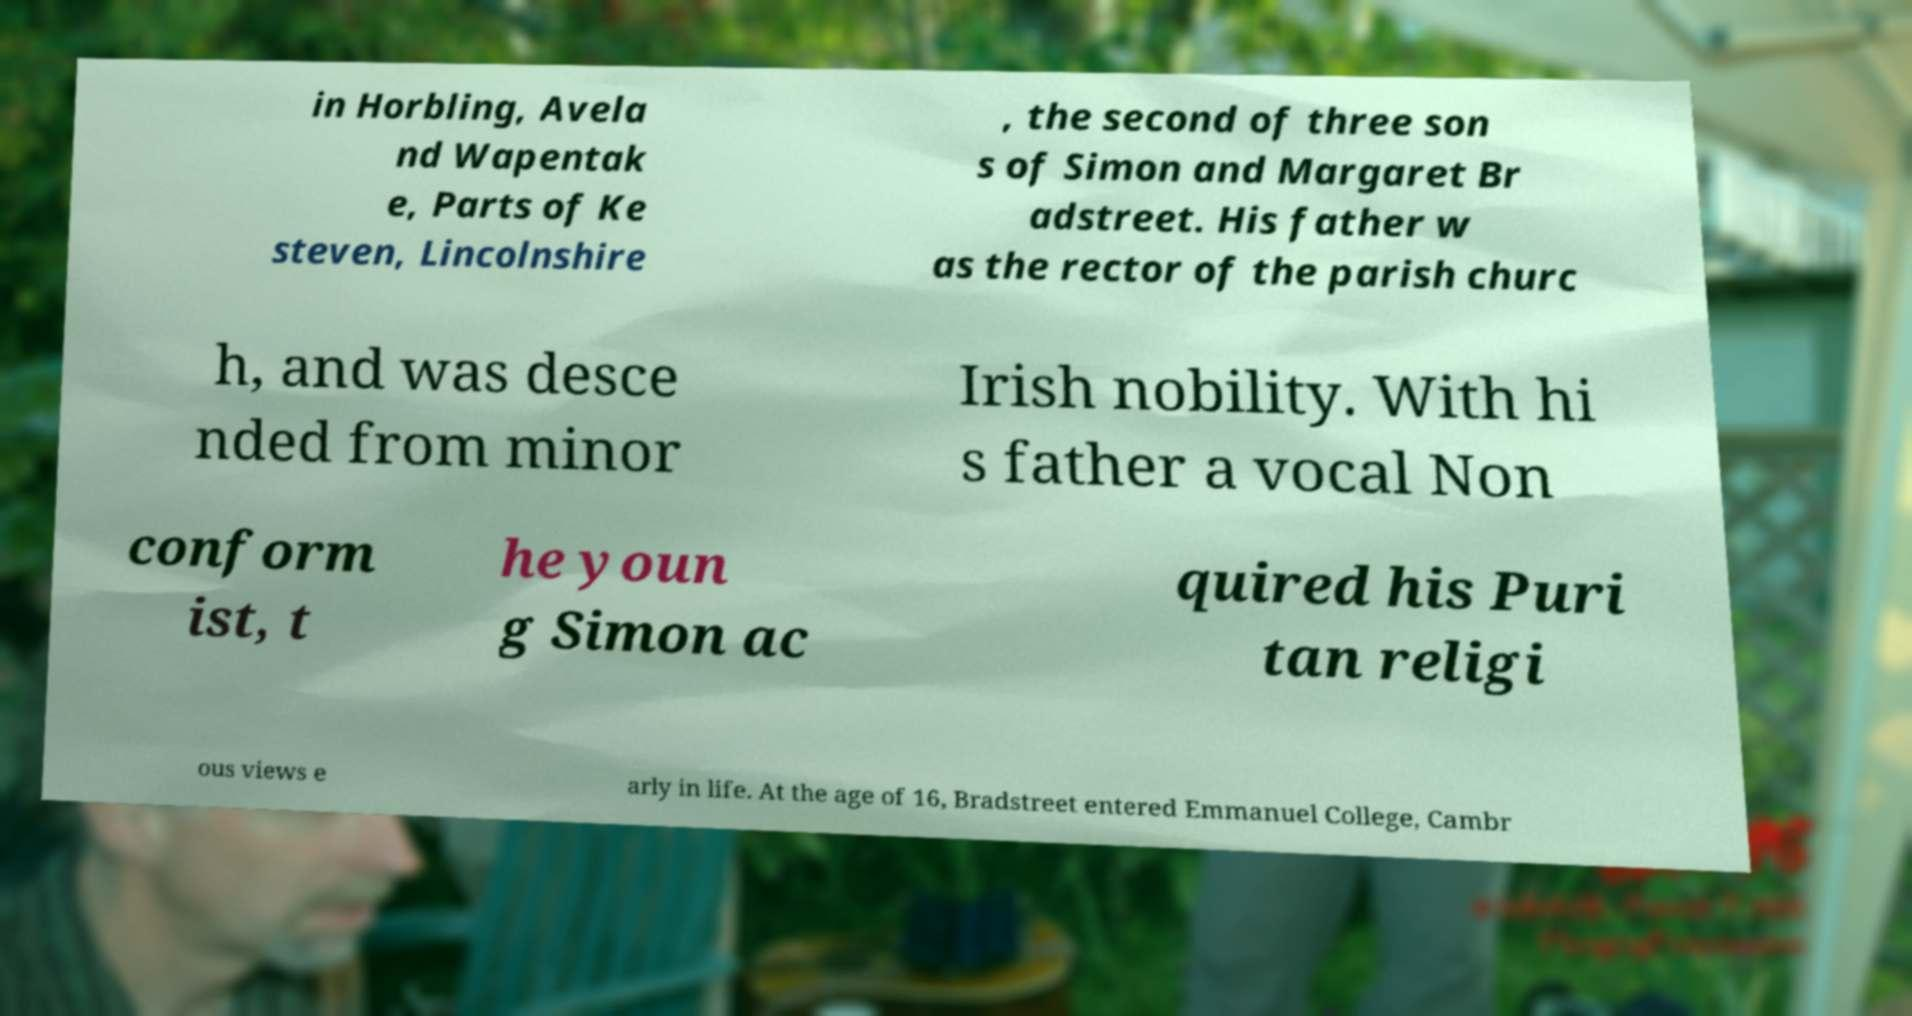What messages or text are displayed in this image? I need them in a readable, typed format. in Horbling, Avela nd Wapentak e, Parts of Ke steven, Lincolnshire , the second of three son s of Simon and Margaret Br adstreet. His father w as the rector of the parish churc h, and was desce nded from minor Irish nobility. With hi s father a vocal Non conform ist, t he youn g Simon ac quired his Puri tan religi ous views e arly in life. At the age of 16, Bradstreet entered Emmanuel College, Cambr 